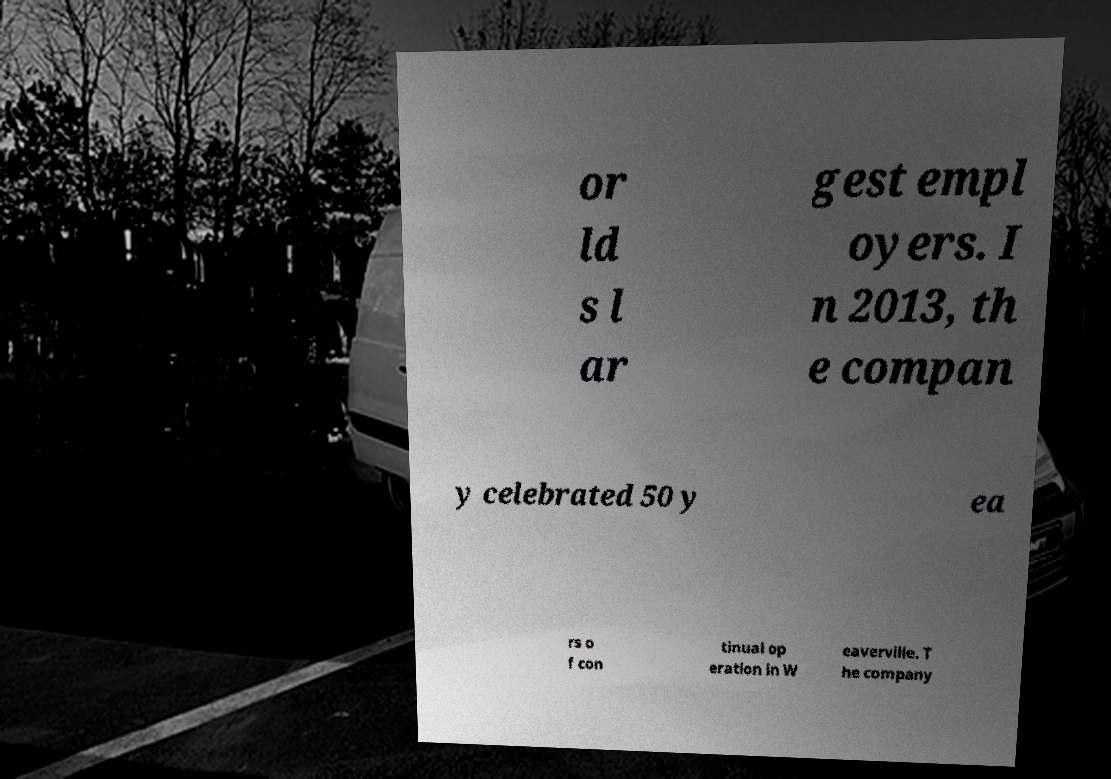Could you assist in decoding the text presented in this image and type it out clearly? or ld s l ar gest empl oyers. I n 2013, th e compan y celebrated 50 y ea rs o f con tinual op eration in W eaverville. T he company 